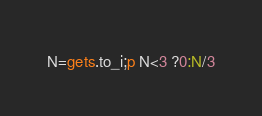Convert code to text. <code><loc_0><loc_0><loc_500><loc_500><_Ruby_>N=gets.to_i;p N<3 ?0:N/3</code> 